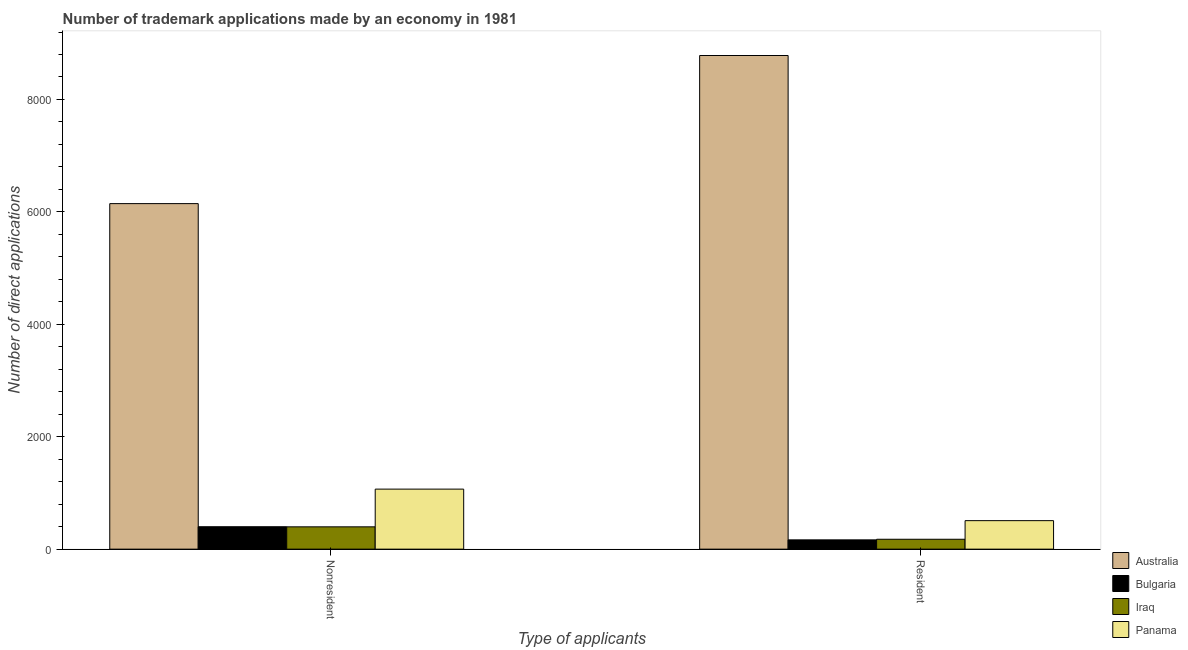How many different coloured bars are there?
Your answer should be very brief. 4. How many groups of bars are there?
Offer a very short reply. 2. Are the number of bars per tick equal to the number of legend labels?
Provide a short and direct response. Yes. Are the number of bars on each tick of the X-axis equal?
Offer a very short reply. Yes. How many bars are there on the 1st tick from the left?
Provide a succinct answer. 4. How many bars are there on the 1st tick from the right?
Offer a terse response. 4. What is the label of the 1st group of bars from the left?
Your answer should be compact. Nonresident. What is the number of trademark applications made by residents in Australia?
Your response must be concise. 8782. Across all countries, what is the maximum number of trademark applications made by non residents?
Ensure brevity in your answer.  6147. Across all countries, what is the minimum number of trademark applications made by non residents?
Offer a very short reply. 397. What is the total number of trademark applications made by residents in the graph?
Make the answer very short. 9630. What is the difference between the number of trademark applications made by residents in Panama and that in Iraq?
Keep it short and to the point. 331. What is the difference between the number of trademark applications made by non residents in Bulgaria and the number of trademark applications made by residents in Panama?
Keep it short and to the point. -108. What is the average number of trademark applications made by residents per country?
Ensure brevity in your answer.  2407.5. What is the difference between the number of trademark applications made by non residents and number of trademark applications made by residents in Bulgaria?
Offer a terse response. 234. In how many countries, is the number of trademark applications made by non residents greater than 1600 ?
Your response must be concise. 1. What is the ratio of the number of trademark applications made by non residents in Australia to that in Bulgaria?
Ensure brevity in your answer.  15.41. Is the number of trademark applications made by non residents in Panama less than that in Bulgaria?
Ensure brevity in your answer.  No. What does the 2nd bar from the right in Resident represents?
Provide a short and direct response. Iraq. How many bars are there?
Ensure brevity in your answer.  8. What is the difference between two consecutive major ticks on the Y-axis?
Your answer should be very brief. 2000. Does the graph contain any zero values?
Provide a succinct answer. No. Where does the legend appear in the graph?
Offer a terse response. Bottom right. How many legend labels are there?
Keep it short and to the point. 4. How are the legend labels stacked?
Offer a terse response. Vertical. What is the title of the graph?
Provide a short and direct response. Number of trademark applications made by an economy in 1981. What is the label or title of the X-axis?
Keep it short and to the point. Type of applicants. What is the label or title of the Y-axis?
Offer a very short reply. Number of direct applications. What is the Number of direct applications in Australia in Nonresident?
Provide a succinct answer. 6147. What is the Number of direct applications in Bulgaria in Nonresident?
Offer a very short reply. 399. What is the Number of direct applications in Iraq in Nonresident?
Offer a terse response. 397. What is the Number of direct applications of Panama in Nonresident?
Offer a terse response. 1068. What is the Number of direct applications of Australia in Resident?
Ensure brevity in your answer.  8782. What is the Number of direct applications in Bulgaria in Resident?
Your answer should be very brief. 165. What is the Number of direct applications of Iraq in Resident?
Offer a terse response. 176. What is the Number of direct applications of Panama in Resident?
Ensure brevity in your answer.  507. Across all Type of applicants, what is the maximum Number of direct applications of Australia?
Provide a short and direct response. 8782. Across all Type of applicants, what is the maximum Number of direct applications of Bulgaria?
Your answer should be very brief. 399. Across all Type of applicants, what is the maximum Number of direct applications of Iraq?
Provide a short and direct response. 397. Across all Type of applicants, what is the maximum Number of direct applications in Panama?
Keep it short and to the point. 1068. Across all Type of applicants, what is the minimum Number of direct applications of Australia?
Offer a terse response. 6147. Across all Type of applicants, what is the minimum Number of direct applications in Bulgaria?
Give a very brief answer. 165. Across all Type of applicants, what is the minimum Number of direct applications in Iraq?
Provide a succinct answer. 176. Across all Type of applicants, what is the minimum Number of direct applications in Panama?
Give a very brief answer. 507. What is the total Number of direct applications in Australia in the graph?
Offer a very short reply. 1.49e+04. What is the total Number of direct applications in Bulgaria in the graph?
Your answer should be very brief. 564. What is the total Number of direct applications in Iraq in the graph?
Your answer should be very brief. 573. What is the total Number of direct applications of Panama in the graph?
Your response must be concise. 1575. What is the difference between the Number of direct applications of Australia in Nonresident and that in Resident?
Give a very brief answer. -2635. What is the difference between the Number of direct applications in Bulgaria in Nonresident and that in Resident?
Your response must be concise. 234. What is the difference between the Number of direct applications of Iraq in Nonresident and that in Resident?
Your answer should be very brief. 221. What is the difference between the Number of direct applications of Panama in Nonresident and that in Resident?
Provide a short and direct response. 561. What is the difference between the Number of direct applications of Australia in Nonresident and the Number of direct applications of Bulgaria in Resident?
Offer a very short reply. 5982. What is the difference between the Number of direct applications in Australia in Nonresident and the Number of direct applications in Iraq in Resident?
Your answer should be very brief. 5971. What is the difference between the Number of direct applications in Australia in Nonresident and the Number of direct applications in Panama in Resident?
Offer a very short reply. 5640. What is the difference between the Number of direct applications of Bulgaria in Nonresident and the Number of direct applications of Iraq in Resident?
Give a very brief answer. 223. What is the difference between the Number of direct applications in Bulgaria in Nonresident and the Number of direct applications in Panama in Resident?
Provide a short and direct response. -108. What is the difference between the Number of direct applications of Iraq in Nonresident and the Number of direct applications of Panama in Resident?
Your answer should be very brief. -110. What is the average Number of direct applications of Australia per Type of applicants?
Your response must be concise. 7464.5. What is the average Number of direct applications in Bulgaria per Type of applicants?
Ensure brevity in your answer.  282. What is the average Number of direct applications of Iraq per Type of applicants?
Your answer should be very brief. 286.5. What is the average Number of direct applications of Panama per Type of applicants?
Your answer should be very brief. 787.5. What is the difference between the Number of direct applications in Australia and Number of direct applications in Bulgaria in Nonresident?
Give a very brief answer. 5748. What is the difference between the Number of direct applications in Australia and Number of direct applications in Iraq in Nonresident?
Ensure brevity in your answer.  5750. What is the difference between the Number of direct applications of Australia and Number of direct applications of Panama in Nonresident?
Your response must be concise. 5079. What is the difference between the Number of direct applications of Bulgaria and Number of direct applications of Iraq in Nonresident?
Your answer should be compact. 2. What is the difference between the Number of direct applications in Bulgaria and Number of direct applications in Panama in Nonresident?
Make the answer very short. -669. What is the difference between the Number of direct applications of Iraq and Number of direct applications of Panama in Nonresident?
Give a very brief answer. -671. What is the difference between the Number of direct applications in Australia and Number of direct applications in Bulgaria in Resident?
Your answer should be compact. 8617. What is the difference between the Number of direct applications in Australia and Number of direct applications in Iraq in Resident?
Ensure brevity in your answer.  8606. What is the difference between the Number of direct applications of Australia and Number of direct applications of Panama in Resident?
Ensure brevity in your answer.  8275. What is the difference between the Number of direct applications in Bulgaria and Number of direct applications in Panama in Resident?
Provide a succinct answer. -342. What is the difference between the Number of direct applications of Iraq and Number of direct applications of Panama in Resident?
Offer a terse response. -331. What is the ratio of the Number of direct applications in Bulgaria in Nonresident to that in Resident?
Ensure brevity in your answer.  2.42. What is the ratio of the Number of direct applications of Iraq in Nonresident to that in Resident?
Your response must be concise. 2.26. What is the ratio of the Number of direct applications in Panama in Nonresident to that in Resident?
Your response must be concise. 2.11. What is the difference between the highest and the second highest Number of direct applications in Australia?
Offer a terse response. 2635. What is the difference between the highest and the second highest Number of direct applications in Bulgaria?
Provide a short and direct response. 234. What is the difference between the highest and the second highest Number of direct applications in Iraq?
Your answer should be compact. 221. What is the difference between the highest and the second highest Number of direct applications in Panama?
Offer a very short reply. 561. What is the difference between the highest and the lowest Number of direct applications of Australia?
Keep it short and to the point. 2635. What is the difference between the highest and the lowest Number of direct applications in Bulgaria?
Make the answer very short. 234. What is the difference between the highest and the lowest Number of direct applications in Iraq?
Provide a short and direct response. 221. What is the difference between the highest and the lowest Number of direct applications of Panama?
Provide a short and direct response. 561. 